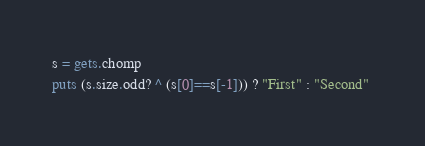<code> <loc_0><loc_0><loc_500><loc_500><_Ruby_>s = gets.chomp
puts (s.size.odd? ^ (s[0]==s[-1])) ? "First" : "Second" </code> 